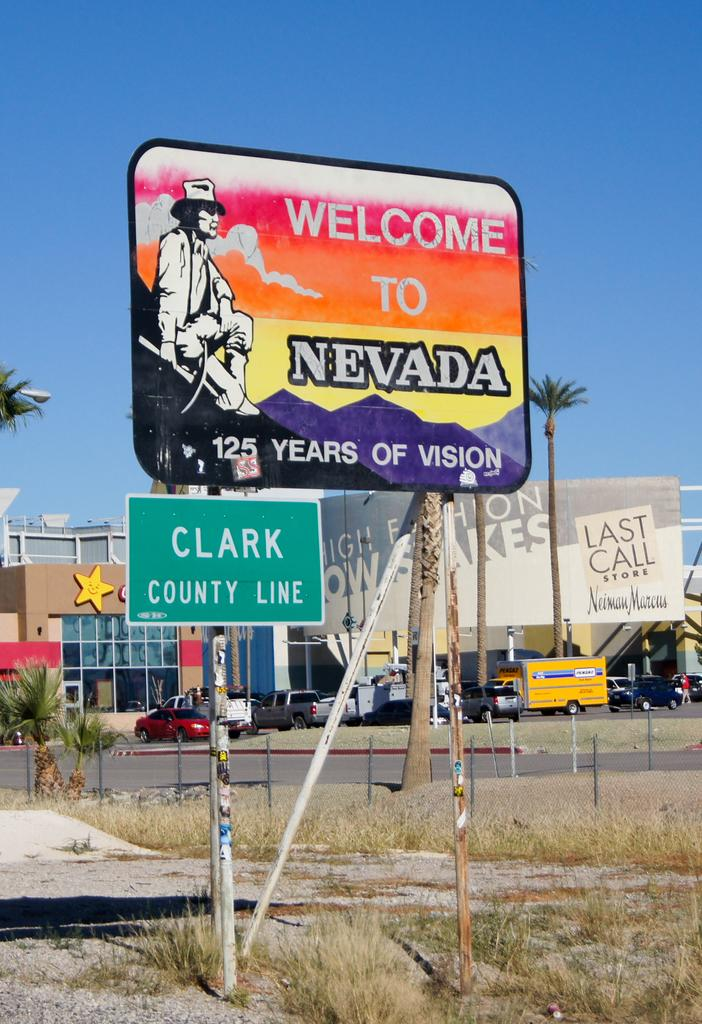<image>
Create a compact narrative representing the image presented. A welcome to Nevada sign displays the Clark County line. 